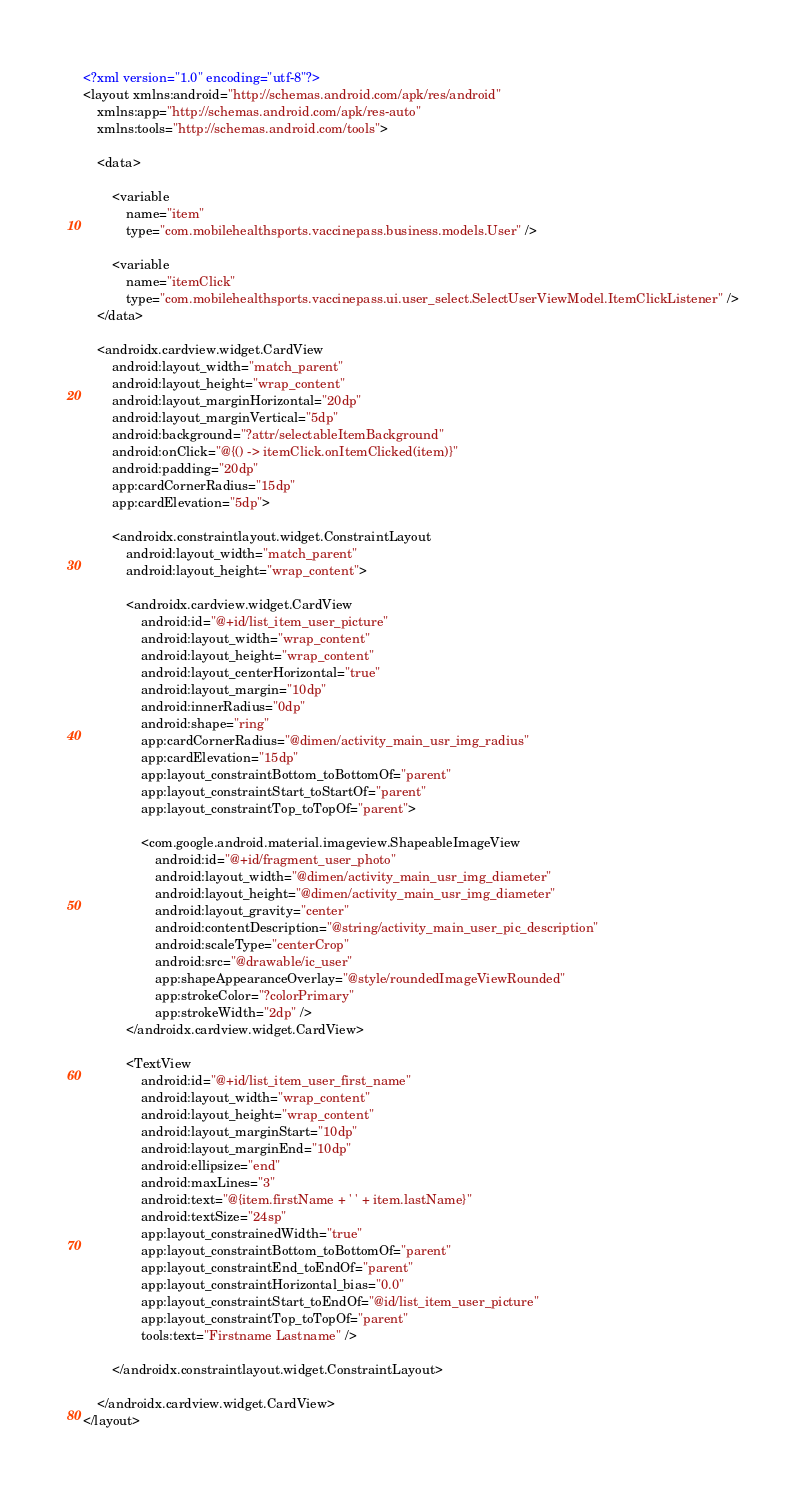Convert code to text. <code><loc_0><loc_0><loc_500><loc_500><_XML_><?xml version="1.0" encoding="utf-8"?>
<layout xmlns:android="http://schemas.android.com/apk/res/android"
    xmlns:app="http://schemas.android.com/apk/res-auto"
    xmlns:tools="http://schemas.android.com/tools">

    <data>

        <variable
            name="item"
            type="com.mobilehealthsports.vaccinepass.business.models.User" />

        <variable
            name="itemClick"
            type="com.mobilehealthsports.vaccinepass.ui.user_select.SelectUserViewModel.ItemClickListener" />
    </data>

    <androidx.cardview.widget.CardView
        android:layout_width="match_parent"
        android:layout_height="wrap_content"
        android:layout_marginHorizontal="20dp"
        android:layout_marginVertical="5dp"
        android:background="?attr/selectableItemBackground"
        android:onClick="@{() -> itemClick.onItemClicked(item)}"
        android:padding="20dp"
        app:cardCornerRadius="15dp"
        app:cardElevation="5dp">

        <androidx.constraintlayout.widget.ConstraintLayout
            android:layout_width="match_parent"
            android:layout_height="wrap_content">

            <androidx.cardview.widget.CardView
                android:id="@+id/list_item_user_picture"
                android:layout_width="wrap_content"
                android:layout_height="wrap_content"
                android:layout_centerHorizontal="true"
                android:layout_margin="10dp"
                android:innerRadius="0dp"
                android:shape="ring"
                app:cardCornerRadius="@dimen/activity_main_usr_img_radius"
                app:cardElevation="15dp"
                app:layout_constraintBottom_toBottomOf="parent"
                app:layout_constraintStart_toStartOf="parent"
                app:layout_constraintTop_toTopOf="parent">

                <com.google.android.material.imageview.ShapeableImageView
                    android:id="@+id/fragment_user_photo"
                    android:layout_width="@dimen/activity_main_usr_img_diameter"
                    android:layout_height="@dimen/activity_main_usr_img_diameter"
                    android:layout_gravity="center"
                    android:contentDescription="@string/activity_main_user_pic_description"
                    android:scaleType="centerCrop"
                    android:src="@drawable/ic_user"
                    app:shapeAppearanceOverlay="@style/roundedImageViewRounded"
                    app:strokeColor="?colorPrimary"
                    app:strokeWidth="2dp" />
            </androidx.cardview.widget.CardView>

            <TextView
                android:id="@+id/list_item_user_first_name"
                android:layout_width="wrap_content"
                android:layout_height="wrap_content"
                android:layout_marginStart="10dp"
                android:layout_marginEnd="10dp"
                android:ellipsize="end"
                android:maxLines="3"
                android:text="@{item.firstName + ' ' + item.lastName}"
                android:textSize="24sp"
                app:layout_constrainedWidth="true"
                app:layout_constraintBottom_toBottomOf="parent"
                app:layout_constraintEnd_toEndOf="parent"
                app:layout_constraintHorizontal_bias="0.0"
                app:layout_constraintStart_toEndOf="@id/list_item_user_picture"
                app:layout_constraintTop_toTopOf="parent"
                tools:text="Firstname Lastname" />

        </androidx.constraintlayout.widget.ConstraintLayout>

    </androidx.cardview.widget.CardView>
</layout></code> 